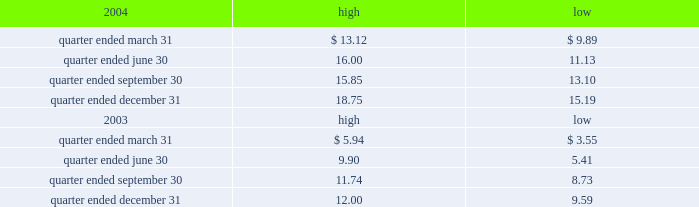Part ii item 5 .
Market for registrant 2019s common equity , related stockholder matters and issuer purchases of equity securities the table presents reported quarterly high and low per share sale prices of our class a common stock on the new york stock exchange ( nyse ) for the years 2004 and 2003. .
On march 18 , 2005 , the closing price of our class a common stock was $ 18.79 per share as reported on the as of march 18 , 2005 , we had 230604932 outstanding shares of class a common stock and 743 registered holders .
In february 2004 , all outstanding shares of our class b common stock were converted into shares of our class a common stock on a one-for-one basis pursuant to the occurrence of the 201cdodge conversion event 201d as defined in our charter .
Our charter prohibits the future issuance of shares of class b common stock .
Also in february 2004 , all outstanding shares of class c common stock were converted into shares of class a common stock on a one-for-one basis .
Our charter permits the issuance of shares of class c common stock in the future .
The information under 201csecurities authorized for issuance under equity compensation plans 201d from the definitive proxy statement is hereby incorporated by reference into item 12 of this annual report .
Dividends we have never paid a dividend on any class of common stock .
We anticipate that we may retain future earnings , if any , to fund the development and growth of our business .
The indentures governing our 93 20448% ( 20448 % ) senior notes due 2009 , our 7.50% ( 7.50 % ) senior notes due 2012 , and our 7.125% ( 7.125 % ) senior notes due 2012 prohibit us from paying dividends to our stockholders unless we satisfy certain financial covenants .
Our borrower subsidiaries are generally prohibited under the terms of the credit facility , subject to certain exceptions , from making to us any direct or indirect distribution , dividend or other payment on account of their limited liability company interests , partnership interests , capital stock or other equity interests , except that , if no default exists or would be created thereby under the credit facility , our borrower subsidiaries may pay cash dividends or make other distributions to us in accordance with the credit facility within certain specified amounts and , in addition , may pay cash dividends or make other distributions to us in respect of our outstanding indebtedness and permitted future indebtedness .
The indentures governing the 12.25% ( 12.25 % ) senior subordinated discount notes due 2008 and the 7.25% ( 7.25 % ) senior subordinated notes due 2011 of american towers , inc .
( ati ) , our principal operating subsidiary , prohibit ati and certain of our other subsidiaries that have guaranteed those notes ( sister guarantors ) from paying dividends and making other payments or distributions to us unless certain .
For the quarter ended june 30 what was the percentage change in the share price from he lowest to the highest? 
Computations: ((16.00 - 11.13) / 11.13)
Answer: 0.43756. 